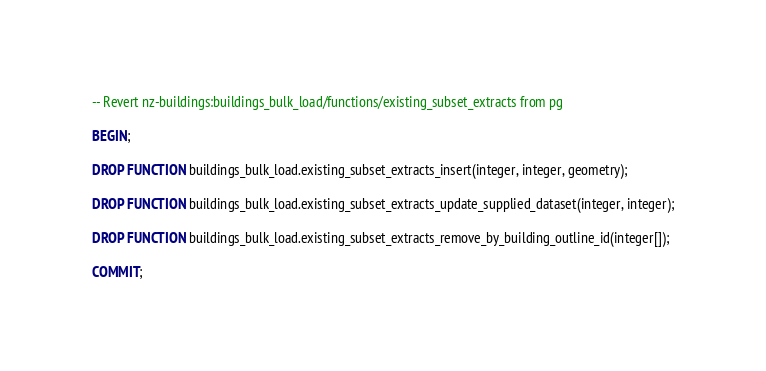<code> <loc_0><loc_0><loc_500><loc_500><_SQL_>-- Revert nz-buildings:buildings_bulk_load/functions/existing_subset_extracts from pg

BEGIN;

DROP FUNCTION buildings_bulk_load.existing_subset_extracts_insert(integer, integer, geometry);

DROP FUNCTION buildings_bulk_load.existing_subset_extracts_update_supplied_dataset(integer, integer);

DROP FUNCTION buildings_bulk_load.existing_subset_extracts_remove_by_building_outline_id(integer[]);

COMMIT;
</code> 